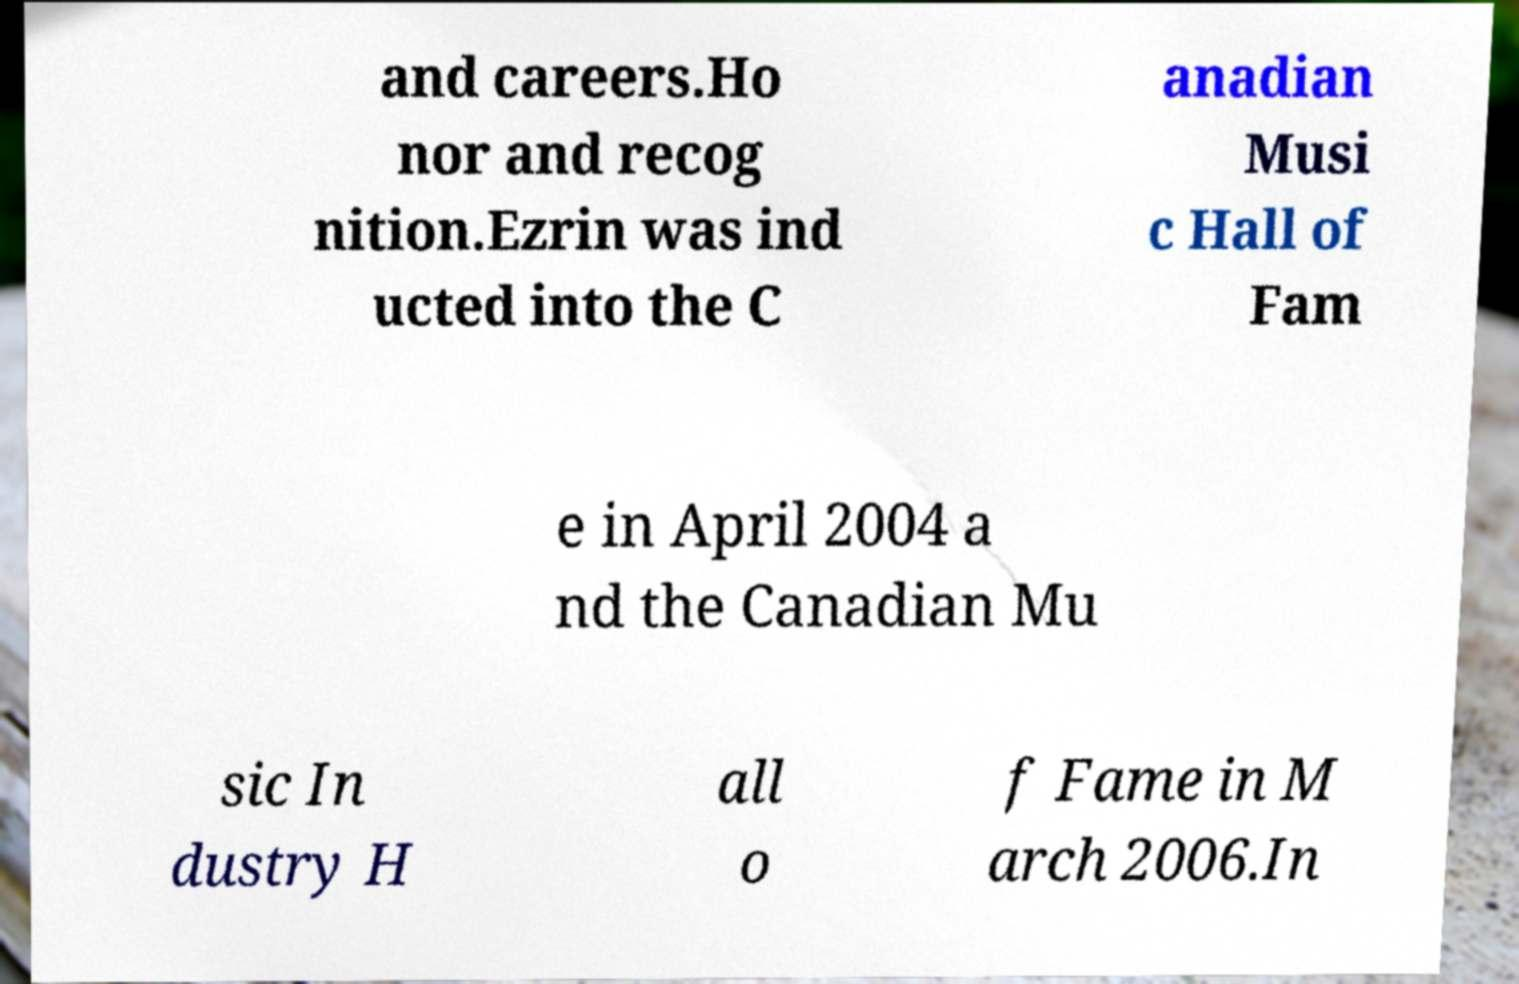Please identify and transcribe the text found in this image. and careers.Ho nor and recog nition.Ezrin was ind ucted into the C anadian Musi c Hall of Fam e in April 2004 a nd the Canadian Mu sic In dustry H all o f Fame in M arch 2006.In 